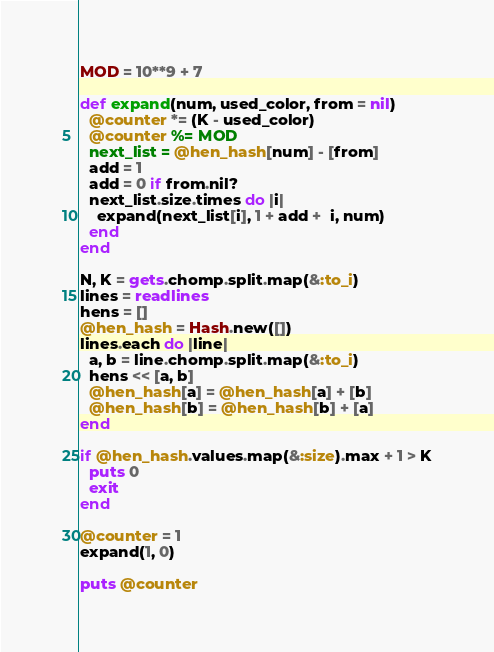<code> <loc_0><loc_0><loc_500><loc_500><_Ruby_>MOD = 10**9 + 7

def expand(num, used_color, from = nil)
  @counter *= (K - used_color)
  @counter %= MOD
  next_list = @hen_hash[num] - [from]
  add = 1
  add = 0 if from.nil?
  next_list.size.times do |i|
    expand(next_list[i], 1 + add +  i, num)
  end
end

N, K = gets.chomp.split.map(&:to_i)
lines = readlines
hens = []
@hen_hash = Hash.new([])
lines.each do |line|
  a, b = line.chomp.split.map(&:to_i)
  hens << [a, b]
  @hen_hash[a] = @hen_hash[a] + [b]
  @hen_hash[b] = @hen_hash[b] + [a]
end

if @hen_hash.values.map(&:size).max + 1 > K
  puts 0
  exit
end

@counter = 1
expand(1, 0)

puts @counter

</code> 